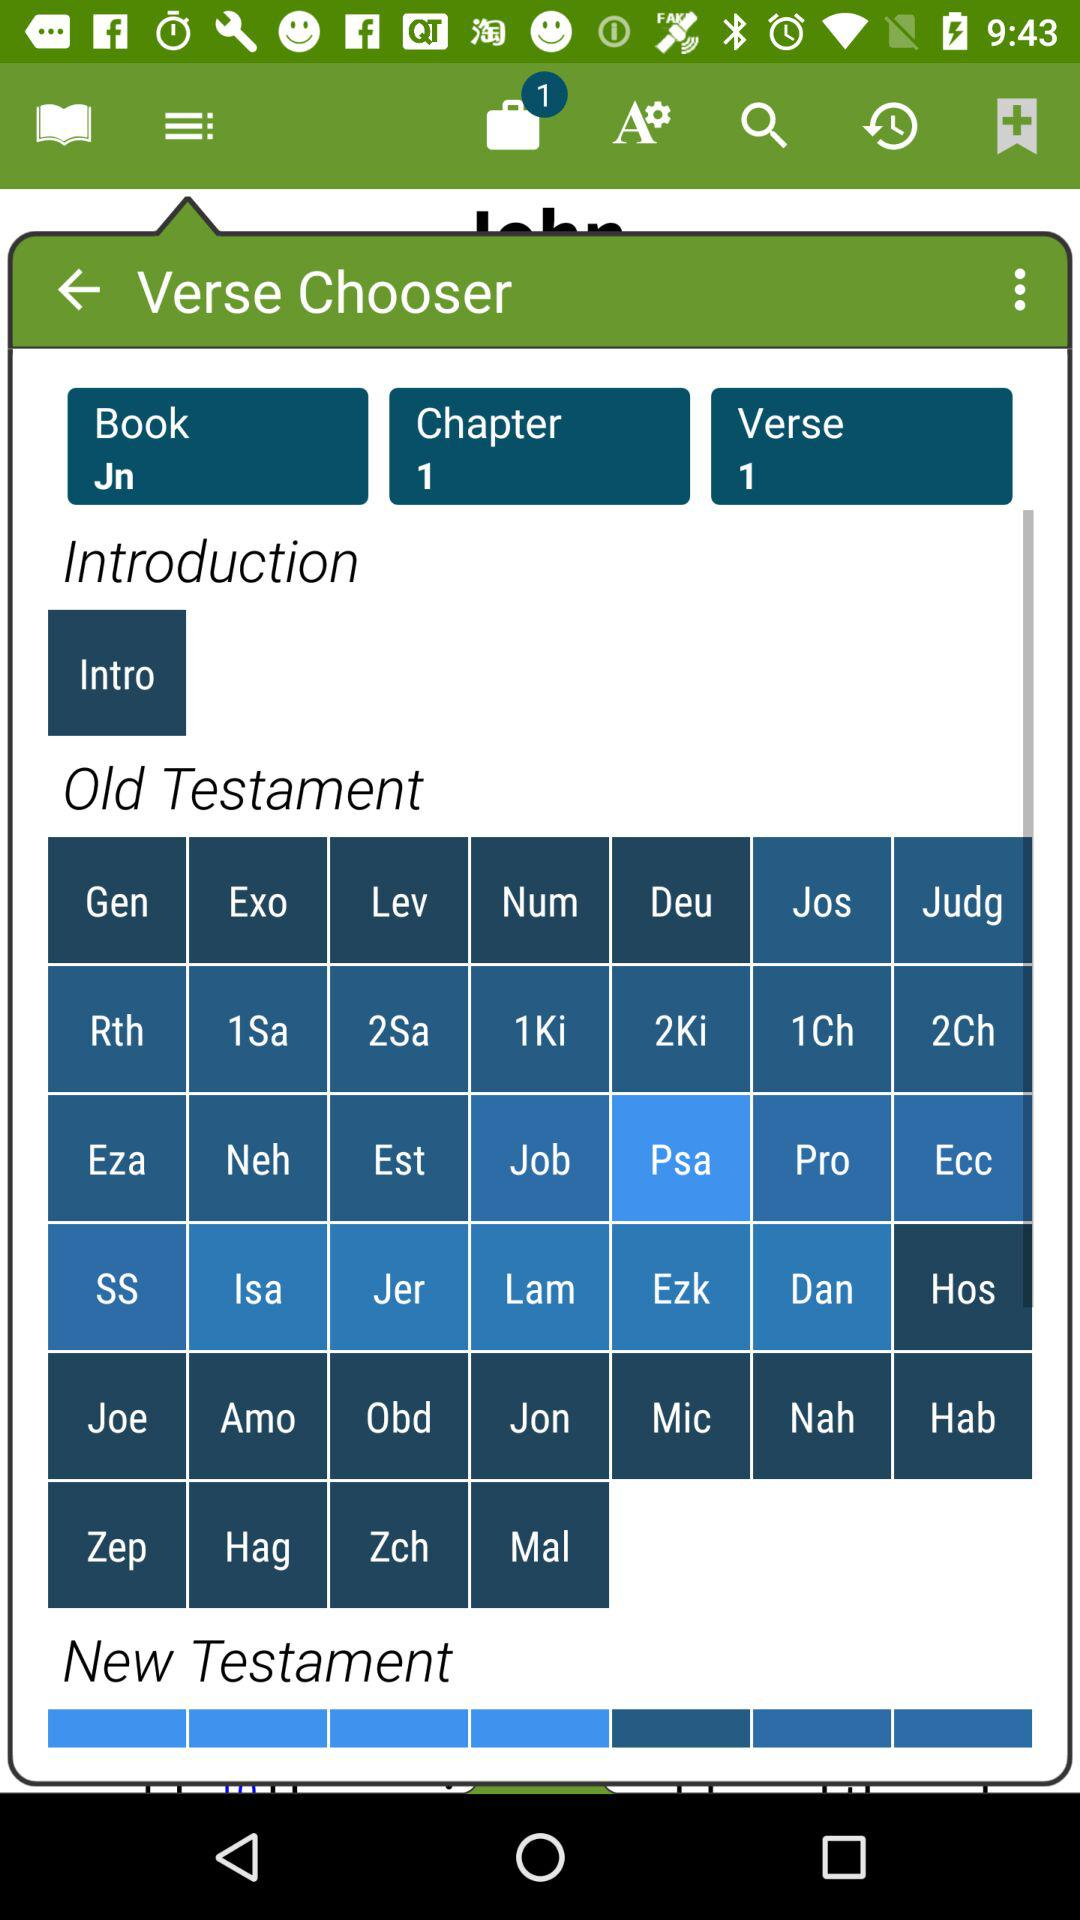How many notifications are there? There is 1 notification. 